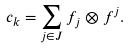<formula> <loc_0><loc_0><loc_500><loc_500>c _ { k } = \sum _ { j \in J } f _ { j } \otimes f ^ { j } .</formula> 